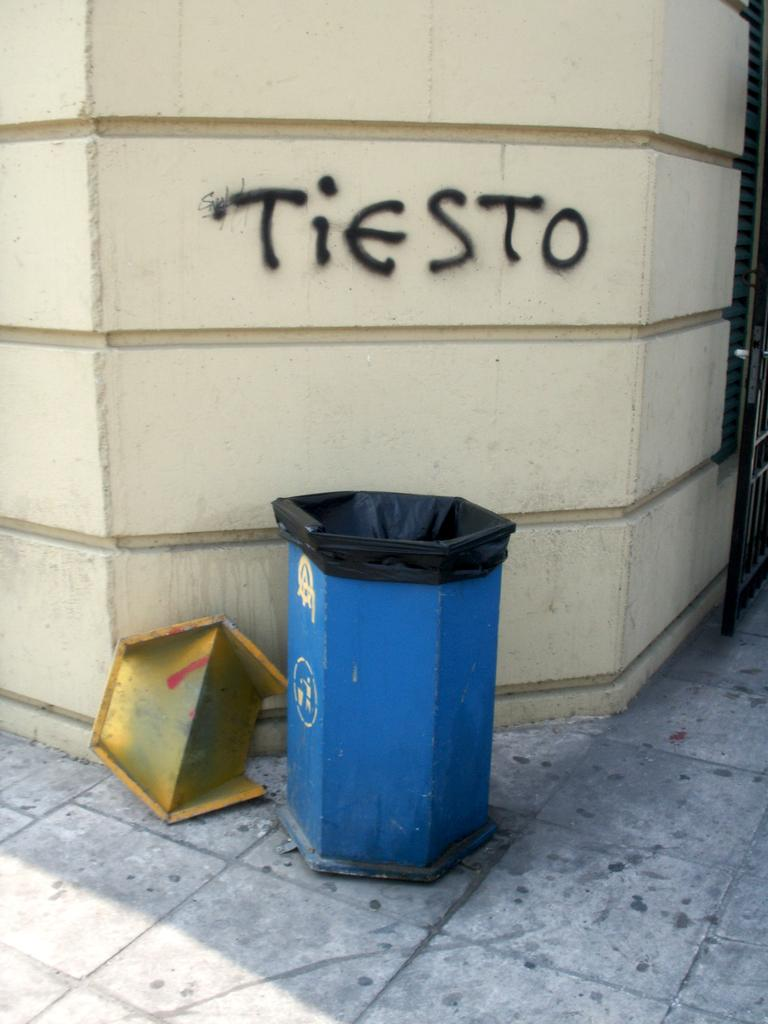<image>
Write a terse but informative summary of the picture. A white wall that has the word Tiesto spray painted on it. 